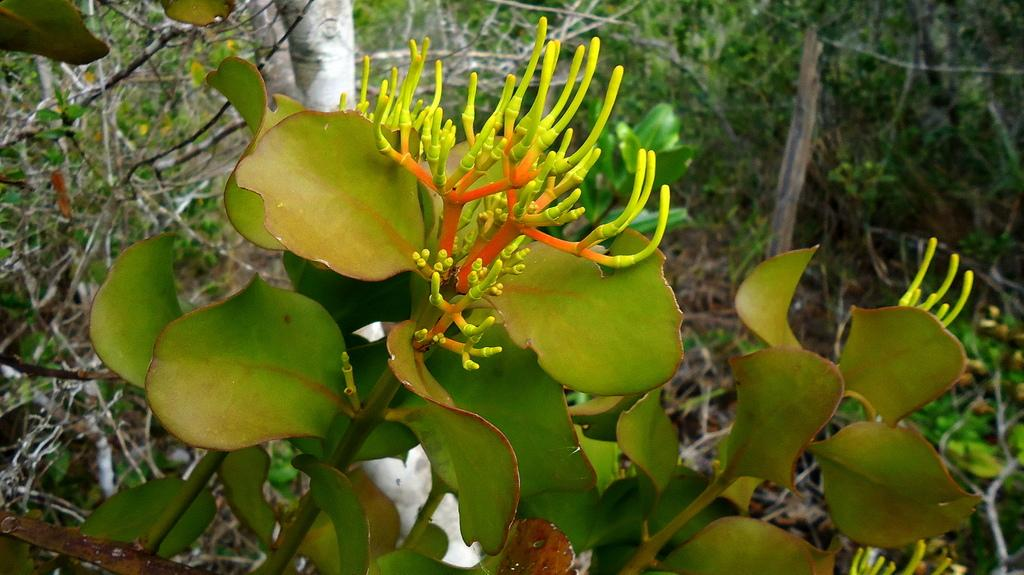What type of vegetation is visible in the front of the image? There are plants in the front of the image. What type of vegetation is visible in the background of the image? There are trees in the background of the image. What type of locket is hanging from the tree in the image? There is no locket present in the image. What type of family can be seen interacting with the plants in the image? There is no family present in the image; it only features plants and trees. 